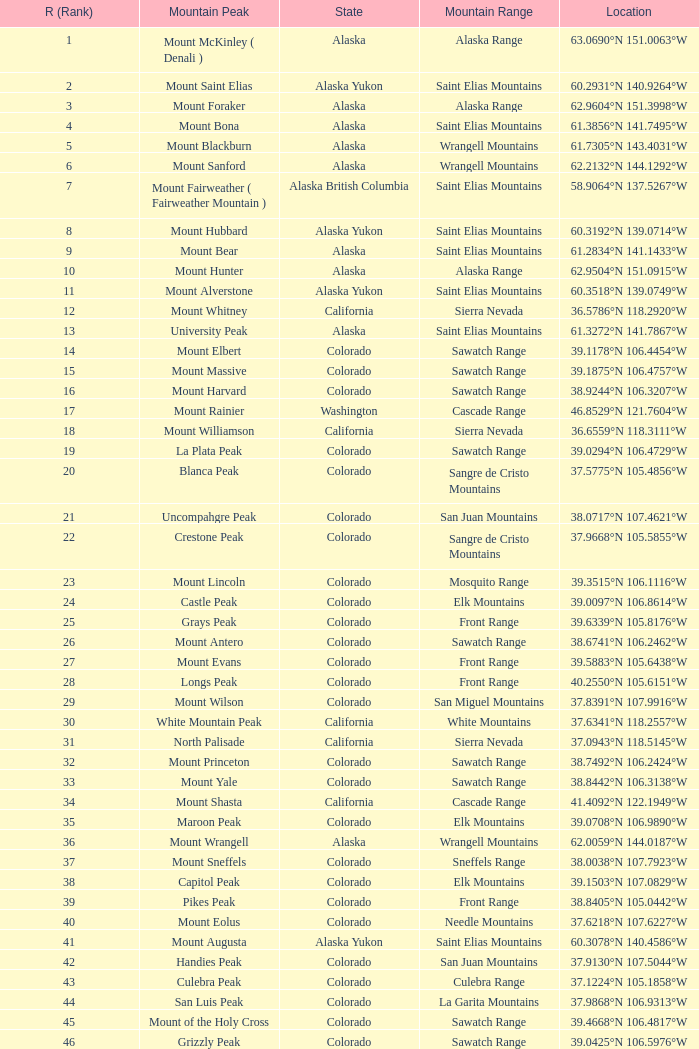4856°w? Blanca Peak. 